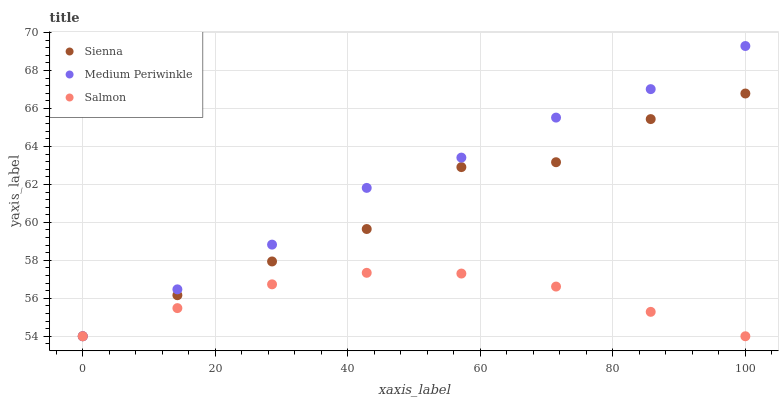Does Salmon have the minimum area under the curve?
Answer yes or no. Yes. Does Medium Periwinkle have the maximum area under the curve?
Answer yes or no. Yes. Does Medium Periwinkle have the minimum area under the curve?
Answer yes or no. No. Does Salmon have the maximum area under the curve?
Answer yes or no. No. Is Salmon the smoothest?
Answer yes or no. Yes. Is Sienna the roughest?
Answer yes or no. Yes. Is Medium Periwinkle the smoothest?
Answer yes or no. No. Is Medium Periwinkle the roughest?
Answer yes or no. No. Does Sienna have the lowest value?
Answer yes or no. Yes. Does Medium Periwinkle have the highest value?
Answer yes or no. Yes. Does Salmon have the highest value?
Answer yes or no. No. Does Medium Periwinkle intersect Sienna?
Answer yes or no. Yes. Is Medium Periwinkle less than Sienna?
Answer yes or no. No. Is Medium Periwinkle greater than Sienna?
Answer yes or no. No. 